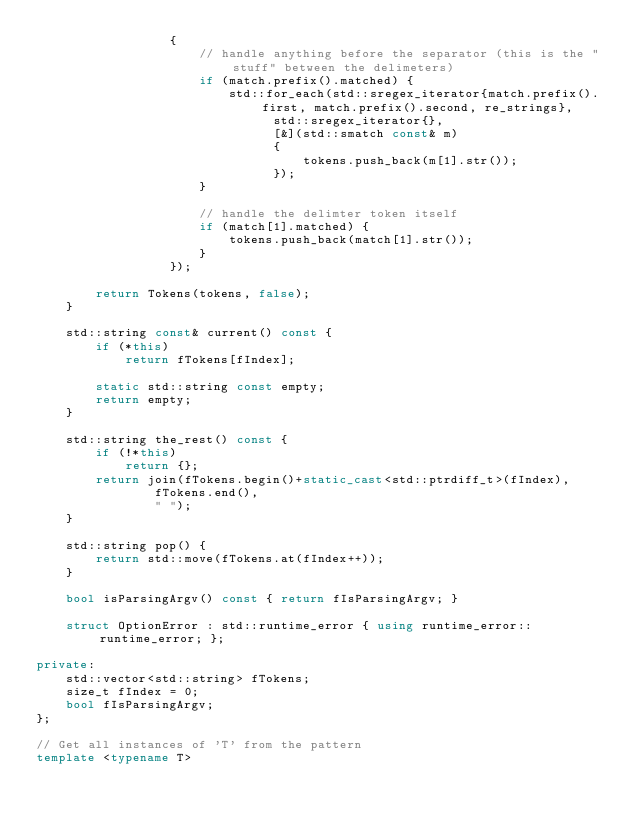Convert code to text. <code><loc_0><loc_0><loc_500><loc_500><_C++_>			      {
				      // handle anything before the separator (this is the "stuff" between the delimeters)
				      if (match.prefix().matched) {
					      std::for_each(std::sregex_iterator{match.prefix().first, match.prefix().second, re_strings},
							    std::sregex_iterator{},
							    [&](std::smatch const& m)
							    {
								    tokens.push_back(m[1].str());
							    });
				      }

				      // handle the delimter token itself
				      if (match[1].matched) {
					      tokens.push_back(match[1].str());
				      }
			      });

		return Tokens(tokens, false);
	}

	std::string const& current() const {
		if (*this)
			return fTokens[fIndex];

		static std::string const empty;
		return empty;
	}

	std::string the_rest() const {
		if (!*this)
			return {};
		return join(fTokens.begin()+static_cast<std::ptrdiff_t>(fIndex),
			    fTokens.end(),
			    " ");
	}

	std::string pop() {
		return std::move(fTokens.at(fIndex++));
	}

	bool isParsingArgv() const { return fIsParsingArgv; }

	struct OptionError : std::runtime_error { using runtime_error::runtime_error; };

private:
	std::vector<std::string> fTokens;
	size_t fIndex = 0;
	bool fIsParsingArgv;
};

// Get all instances of 'T' from the pattern
template <typename T></code> 